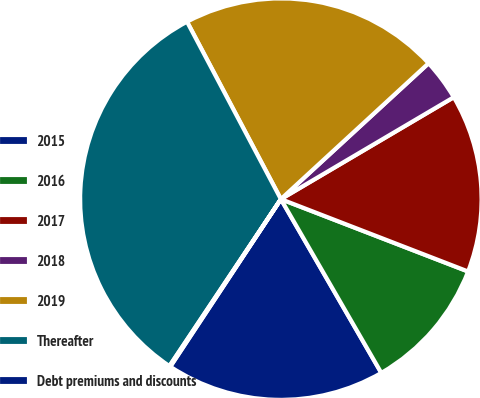Convert chart to OTSL. <chart><loc_0><loc_0><loc_500><loc_500><pie_chart><fcel>2015<fcel>2016<fcel>2017<fcel>2018<fcel>2019<fcel>Thereafter<fcel>Debt premiums and discounts<nl><fcel>17.63%<fcel>10.79%<fcel>14.35%<fcel>3.36%<fcel>20.91%<fcel>32.89%<fcel>0.08%<nl></chart> 